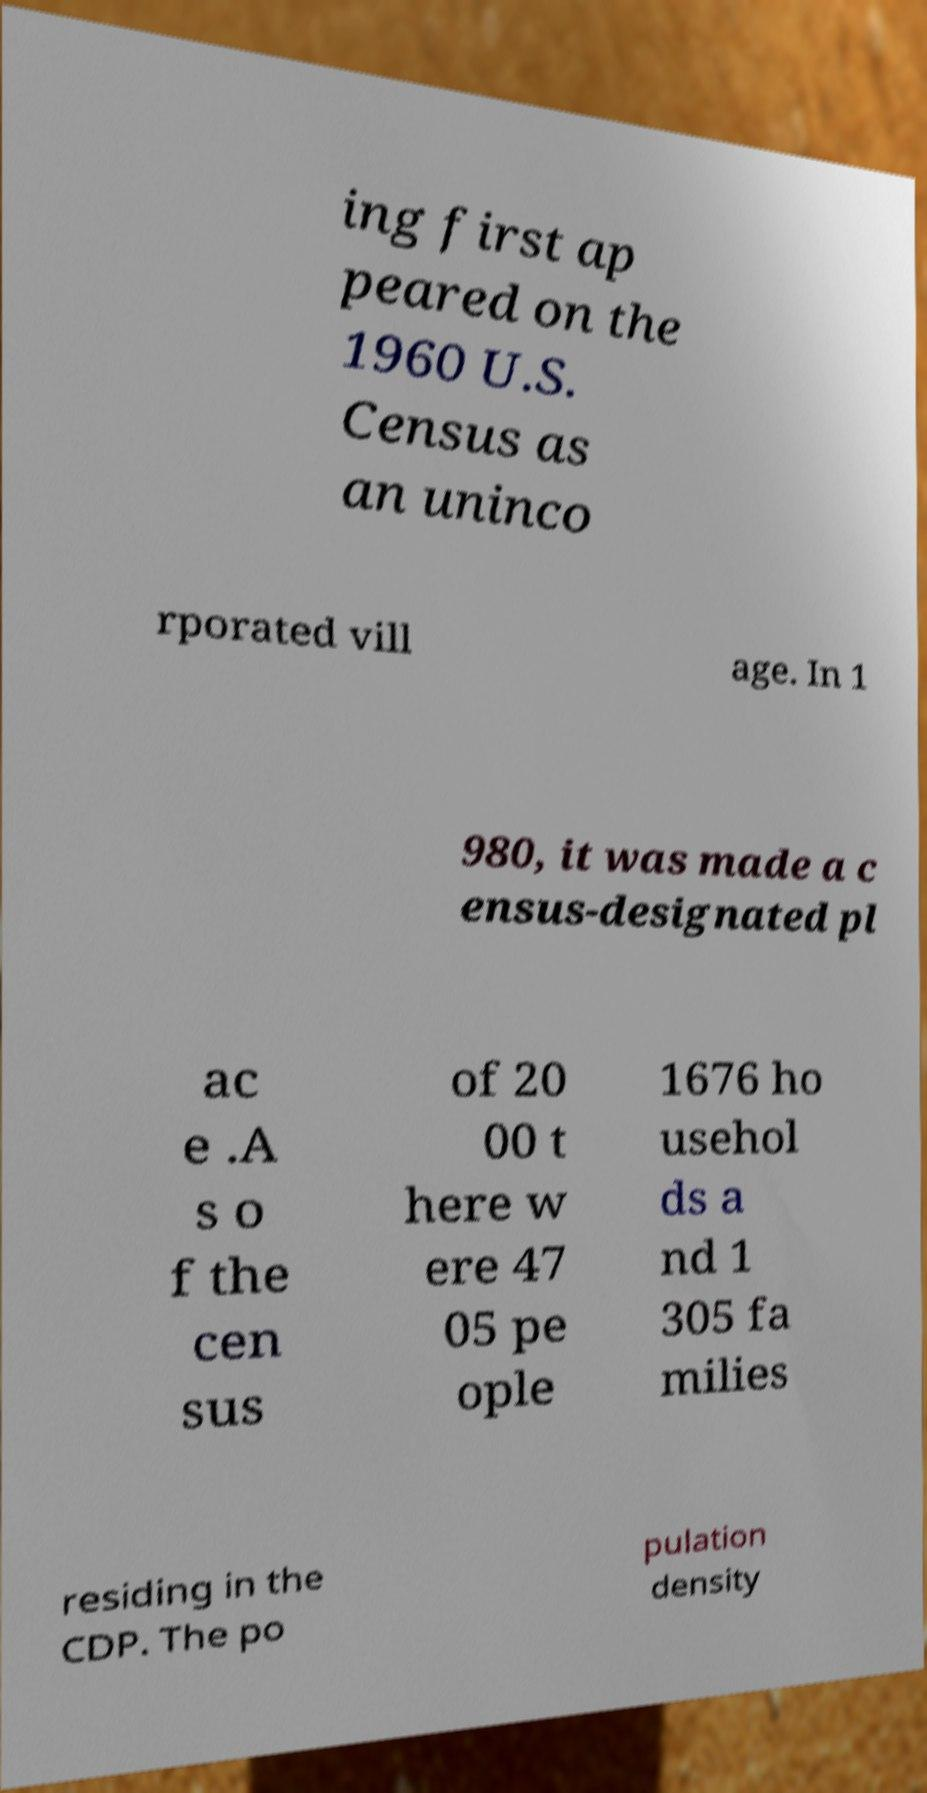I need the written content from this picture converted into text. Can you do that? ing first ap peared on the 1960 U.S. Census as an uninco rporated vill age. In 1 980, it was made a c ensus-designated pl ac e .A s o f the cen sus of 20 00 t here w ere 47 05 pe ople 1676 ho usehol ds a nd 1 305 fa milies residing in the CDP. The po pulation density 